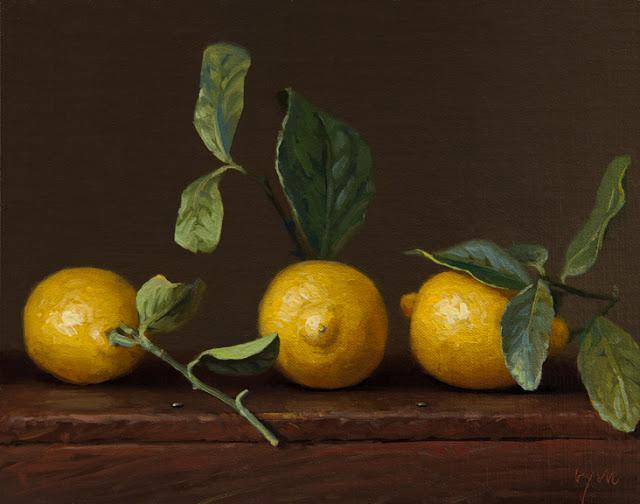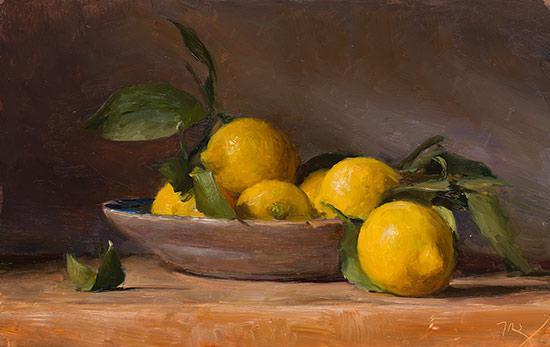The first image is the image on the left, the second image is the image on the right. Evaluate the accuracy of this statement regarding the images: "Some lemons are in a bowl.". Is it true? Answer yes or no. Yes. The first image is the image on the left, the second image is the image on the right. Given the left and right images, does the statement "There are three whole lemons lined up in a row in at least one of the images." hold true? Answer yes or no. Yes. 